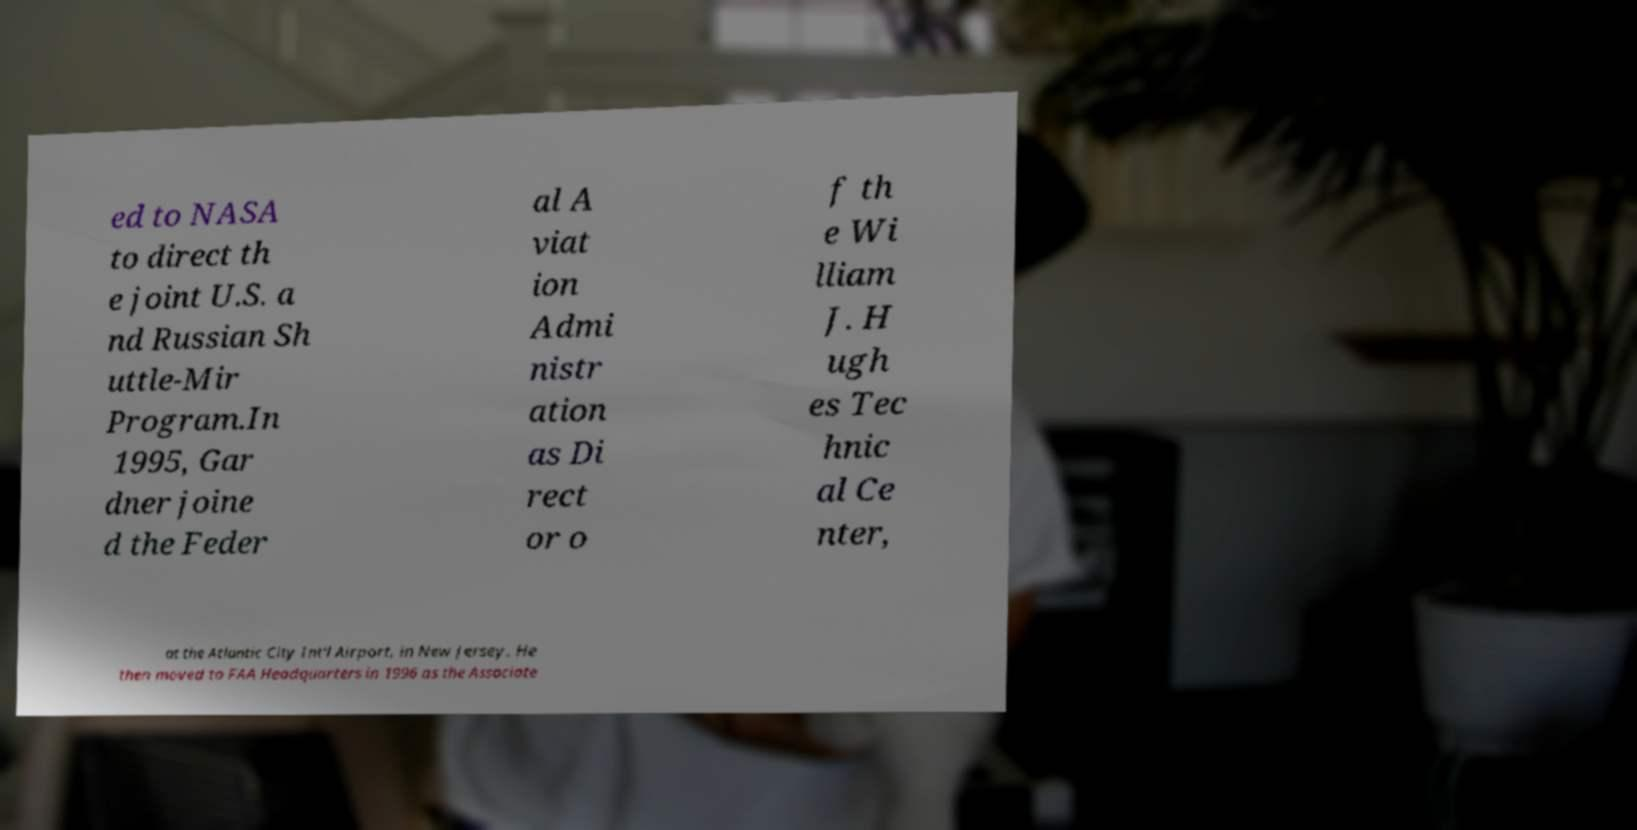For documentation purposes, I need the text within this image transcribed. Could you provide that? ed to NASA to direct th e joint U.S. a nd Russian Sh uttle-Mir Program.In 1995, Gar dner joine d the Feder al A viat ion Admi nistr ation as Di rect or o f th e Wi lliam J. H ugh es Tec hnic al Ce nter, at the Atlantic City Int'l Airport, in New Jersey. He then moved to FAA Headquarters in 1996 as the Associate 